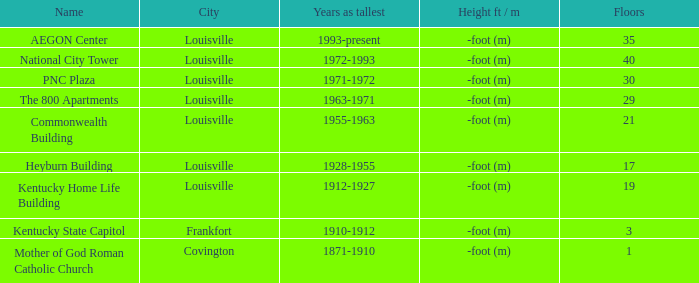What construction in louisville featured more than 35 storeys? National City Tower. 